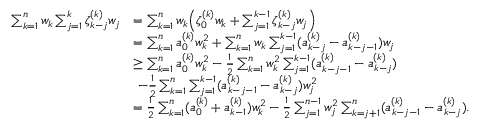<formula> <loc_0><loc_0><loc_500><loc_500>\begin{array} { r l } { \sum _ { k = 1 } ^ { n } w _ { k } \sum _ { j = 1 } ^ { k } \zeta _ { k - j } ^ { ( k ) } w _ { j } } & { = \sum _ { k = 1 } ^ { n } w _ { k } \left ( \zeta _ { 0 } ^ { ( k ) } w _ { k } + \sum _ { j = 1 } ^ { k - 1 } \zeta _ { k - j } ^ { ( k ) } w _ { j } \right ) } \\ & { = \sum _ { k = 1 } ^ { n } a _ { 0 } ^ { ( k ) } w _ { k } ^ { 2 } + \sum _ { k = 1 } ^ { n } w _ { k } \sum _ { j = 1 } ^ { k - 1 } ( a _ { k - j } ^ { ( k ) } - a _ { k - j - 1 } ^ { ( k ) } ) w _ { j } } \\ & { \geq \sum _ { k = 1 } ^ { n } a _ { 0 } ^ { ( k ) } w _ { k } ^ { 2 } - \frac { 1 } { 2 } \sum _ { k = 1 } ^ { n } w _ { k } ^ { 2 } \sum _ { j = 1 } ^ { k - 1 } ( a _ { k - j - 1 } ^ { ( k ) } - a _ { k - j } ^ { ( k ) } ) } \\ & { - \frac { 1 } { 2 } \sum _ { k = 1 } ^ { n } \sum _ { j = 1 } ^ { k - 1 } ( a _ { k - j - 1 } ^ { ( k ) } - a _ { k - j } ^ { ( k ) } ) w _ { j } ^ { 2 } } \\ & { = \frac { 1 } { 2 } \sum _ { k = 1 } ^ { n } ( a _ { 0 } ^ { ( k ) } + a _ { k - 1 } ^ { ( k ) } ) w _ { k } ^ { 2 } - \frac { 1 } { 2 } \sum _ { j = 1 } ^ { n - 1 } w _ { j } ^ { 2 } \sum _ { k = j + 1 } ^ { n } ( a _ { k - j - 1 } ^ { ( k ) } - a _ { k - j } ^ { ( k ) } ) . } \end{array}</formula> 